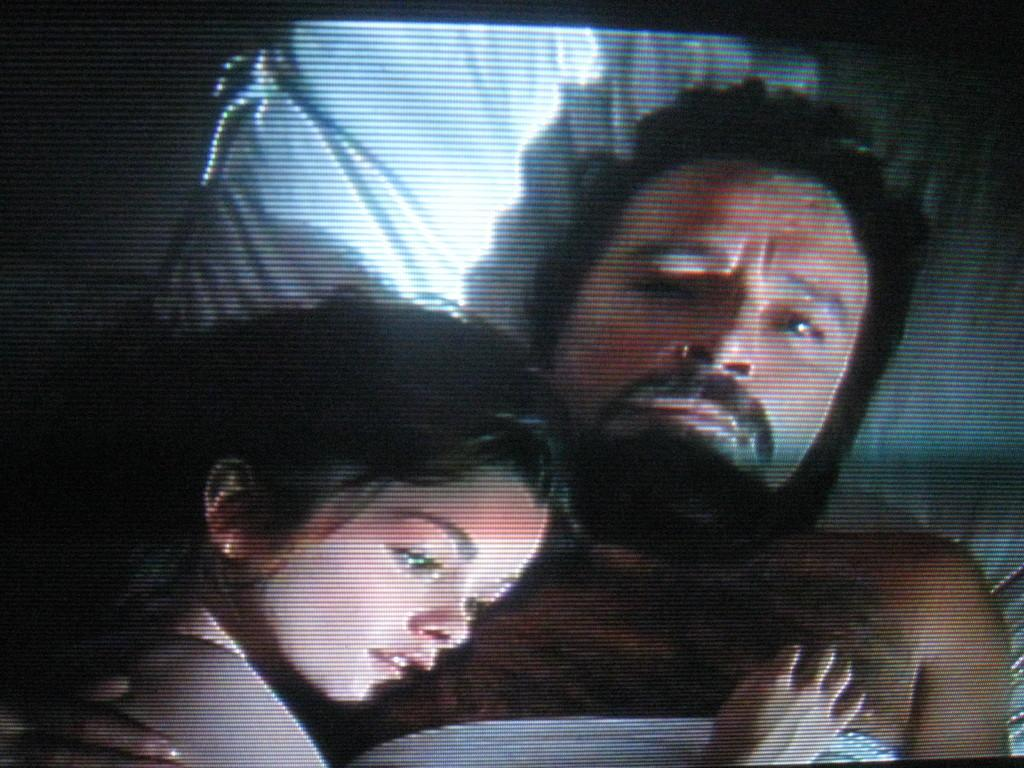What is the main object in the image? There is a display screen in the image. What can be seen on the display screen? The display screen shows a picture of a man and a girl. What are the man and the girl doing in the picture? The man and the girl are lying on a pillow in the picture. What verse is being recited by the man and the girl in the image? There is no indication in the image that the man and the girl are reciting a verse. --- Facts: 1. There is a car in the image. 2. The car is parked on the street. 3. There are trees on both sides of the street. 4. The sky is visible in the image. Absurd Topics: dance, parrot, ocean Conversation: What is the main subject of the image? The main subject of the image is a car. Where is the car located in the image? The car is parked on the street. What can be seen on both sides of the street in the image? There are trees on both sides of the street. What is visible in the background of the image? The sky is visible in the image. Reasoning: Let's think step by step in order to produce the conversation. We start by identifying the main subject in the image, which is the car. Then, we describe the location of the car, mentioning that it is parked on the street. Next, we expand the conversation to include the surrounding environment, noting the presence of trees on both sides of the street. Finally, we mention the sky, which is visible in the background of the image. Absurd Question/Answer: Can you see any parrots flying over the ocean in the image? There is no ocean or parrots present in the image; it features a car parked on the street with trees on both sides. 